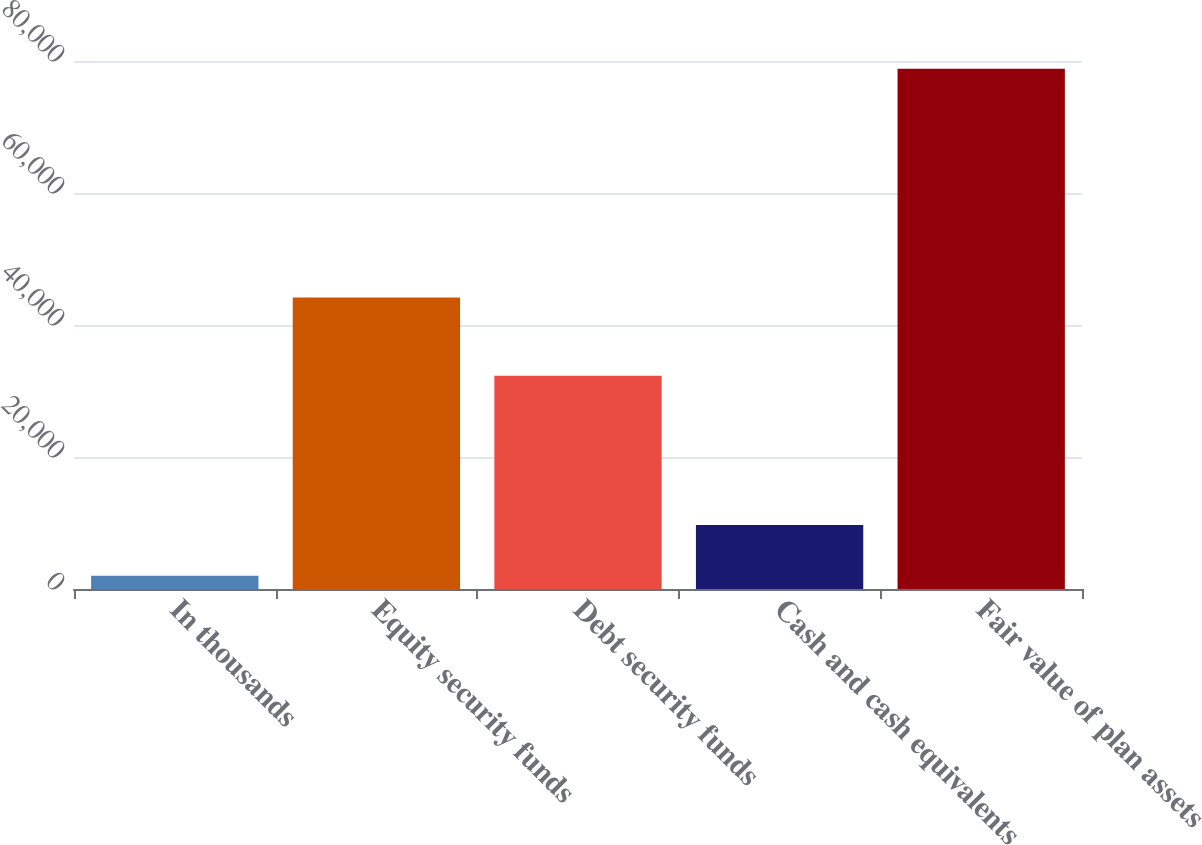Convert chart. <chart><loc_0><loc_0><loc_500><loc_500><bar_chart><fcel>In thousands<fcel>Equity security funds<fcel>Debt security funds<fcel>Cash and cash equivalents<fcel>Fair value of plan assets<nl><fcel>2008<fcel>44152<fcel>32326<fcel>9691.5<fcel>78843<nl></chart> 